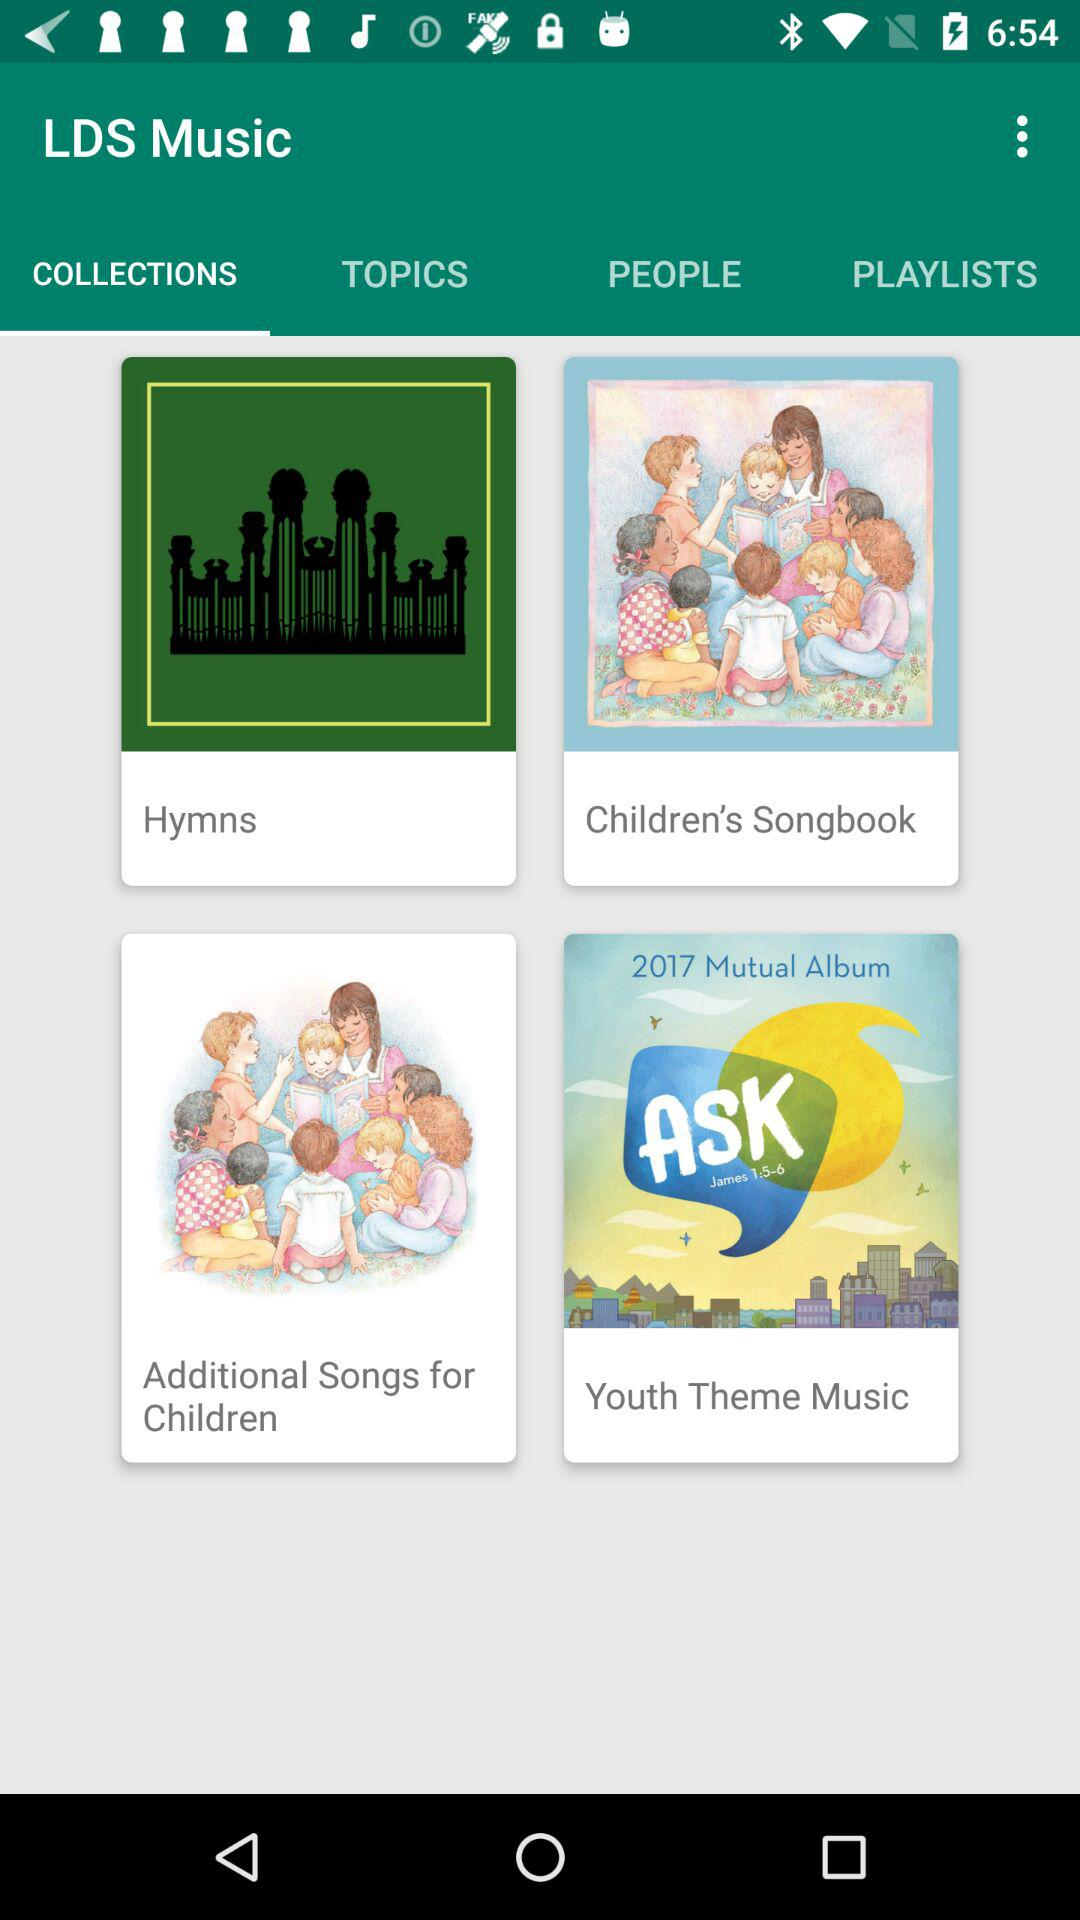Which tab am I on? You are on the tab "COLLECTIONS". 